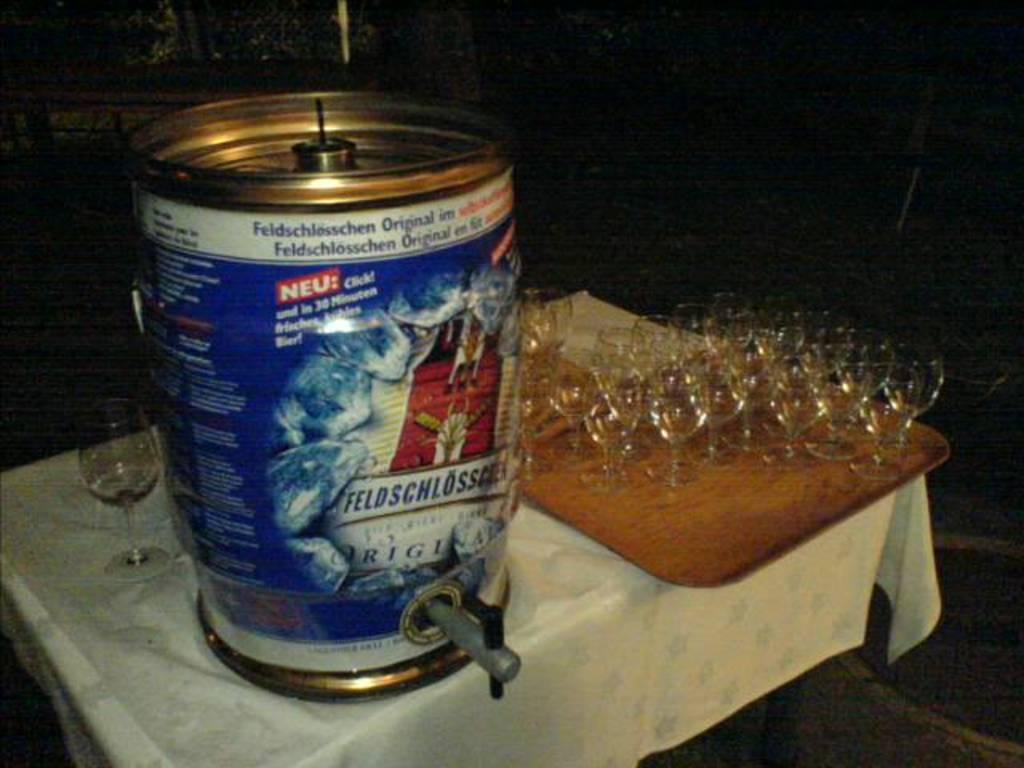What object is on the table in the image? There is a can on the table in the image. What else can be seen on the table or nearby in the image? There are glasses on a tray in the image. What type of news can be heard coming from the ladybug in the image? There is no ladybug present in the image, and therefore no news can be heard from it. 